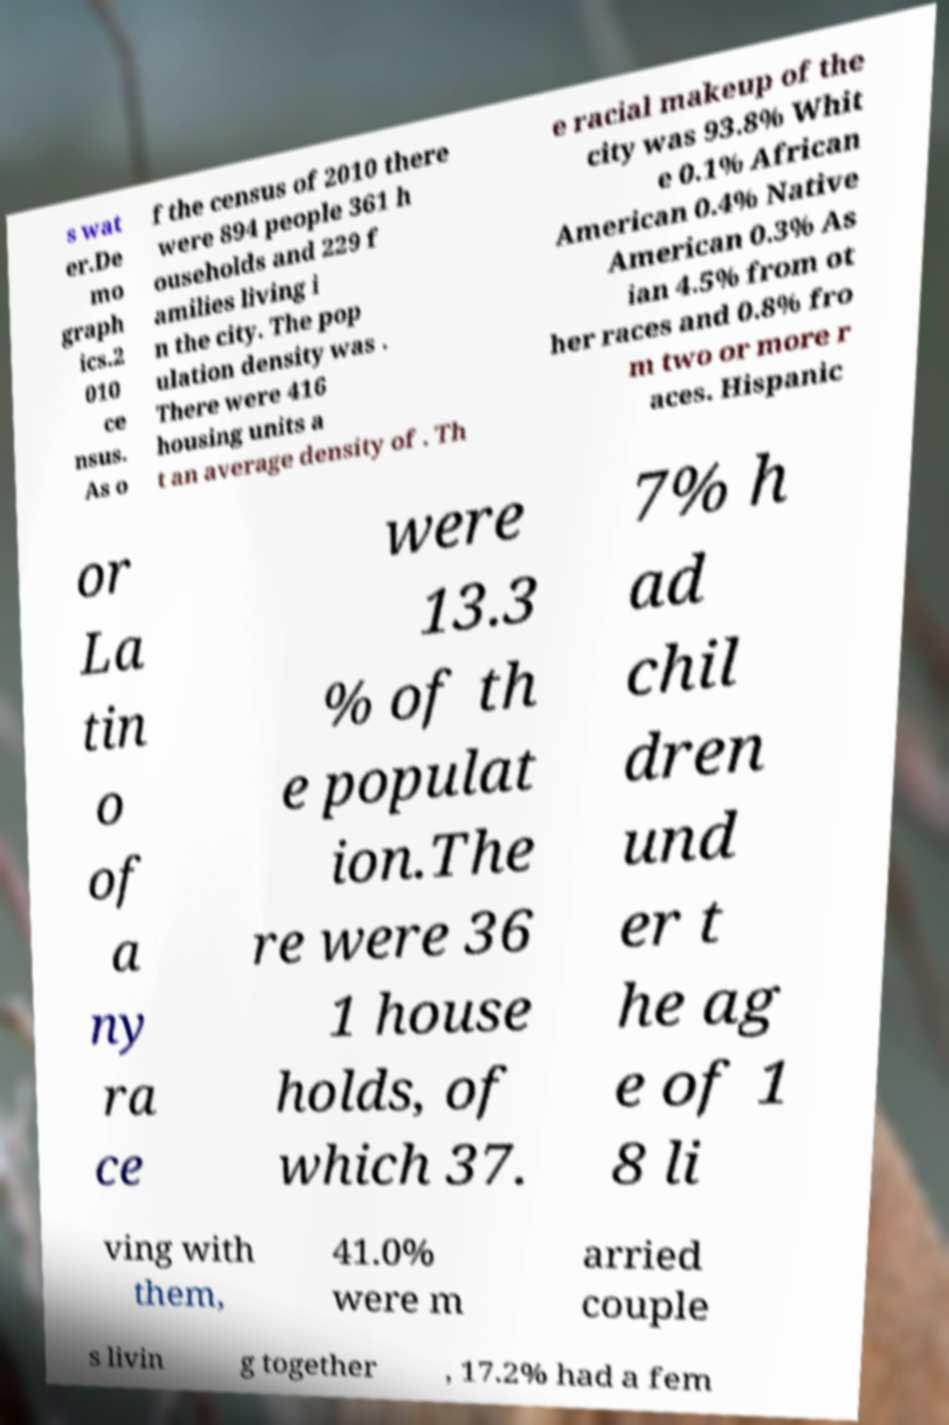Please read and relay the text visible in this image. What does it say? s wat er.De mo graph ics.2 010 ce nsus. As o f the census of 2010 there were 894 people 361 h ouseholds and 229 f amilies living i n the city. The pop ulation density was . There were 416 housing units a t an average density of . Th e racial makeup of the city was 93.8% Whit e 0.1% African American 0.4% Native American 0.3% As ian 4.5% from ot her races and 0.8% fro m two or more r aces. Hispanic or La tin o of a ny ra ce were 13.3 % of th e populat ion.The re were 36 1 house holds, of which 37. 7% h ad chil dren und er t he ag e of 1 8 li ving with them, 41.0% were m arried couple s livin g together , 17.2% had a fem 